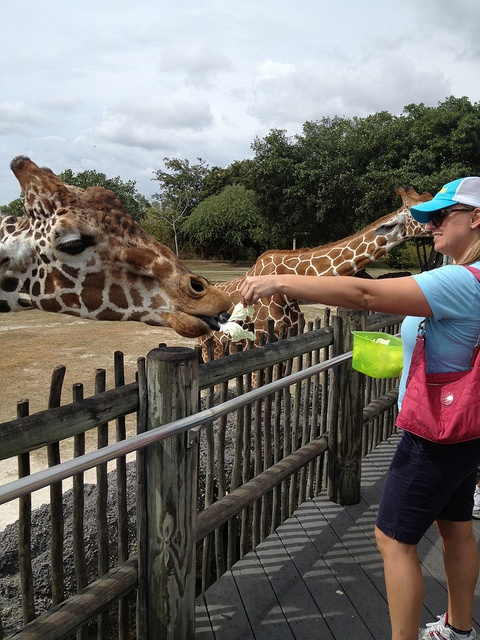Describe the objects in this image and their specific colors. I can see people in lightgray, black, maroon, gray, and brown tones, giraffe in lightgray, black, gray, and maroon tones, giraffe in lightgray, gray, brown, black, and maroon tones, handbag in lightgray, maroon, and brown tones, and bowl in lightgray, khaki, olive, and lightgreen tones in this image. 